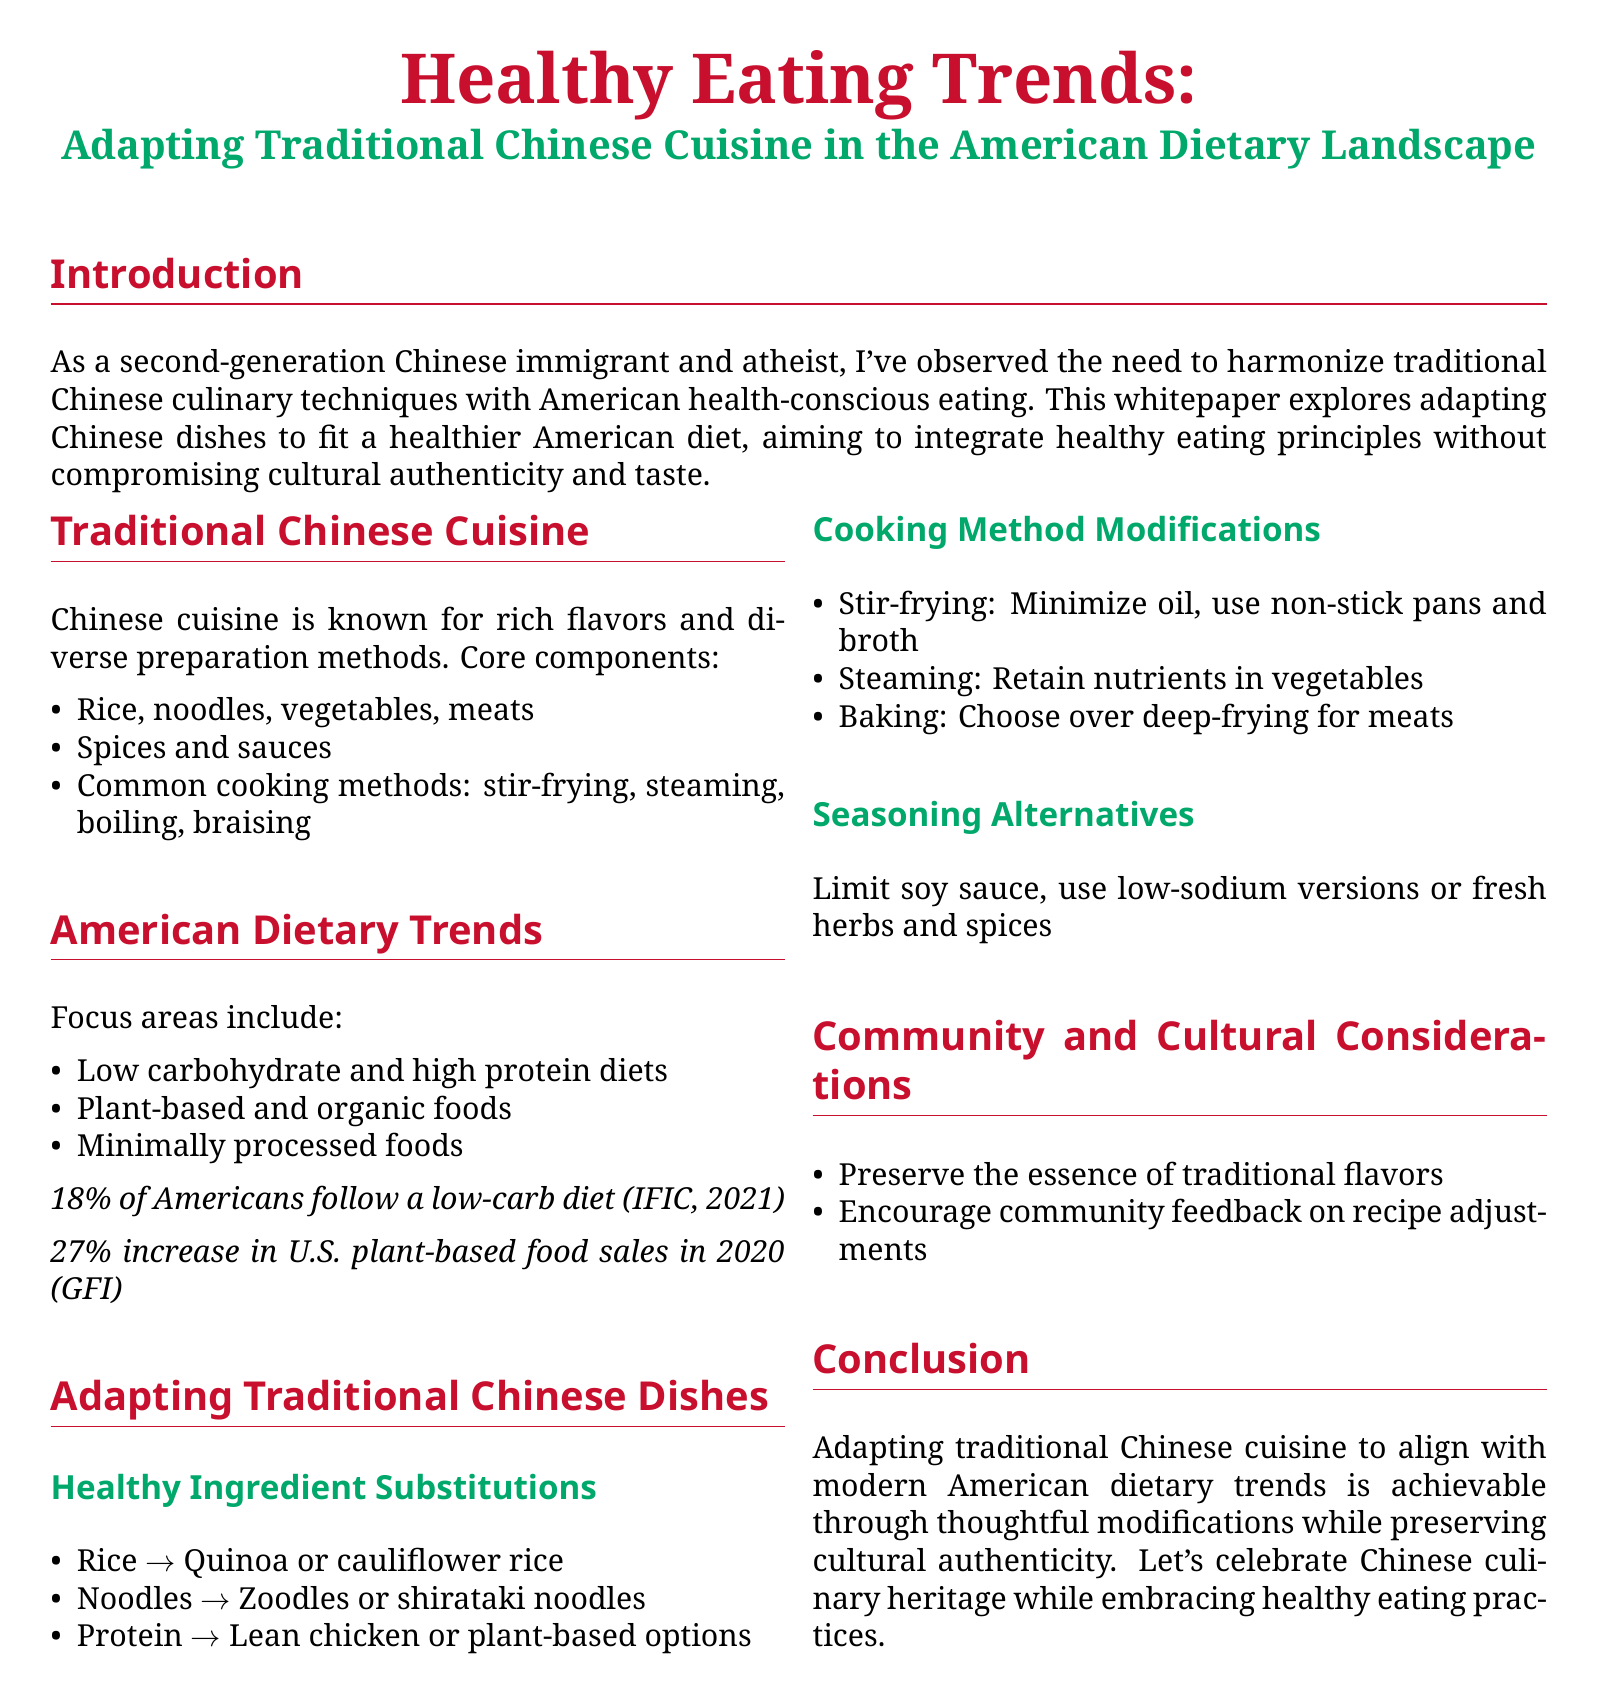What is the focus of American dietary trends? The focus areas include low carbohydrate and high protein diets, plant-based and organic foods, and minimally processed foods.
Answer: Low carbohydrate and high protein diets, plant-based and organic foods, minimally processed foods What percentage of Americans follow a low-carb diet? The document states that 18% of Americans follow a low-carb diet according to IFIC, 2021.
Answer: 18% What is a healthy substitution for rice mentioned in the document? The document suggests quinoa or cauliflower rice as substitutes for rice.
Answer: Quinoa or cauliflower rice What cooking method is recommended to retain nutrients in vegetables? The document advises steaming as a method to retain nutrients in vegetables.
Answer: Steaming What seasoning alternative is suggested to limit in traditional Chinese dishes? The document recommends limiting soy sauce.
Answer: Soy sauce How has U.S. plant-based food sales changed in 2020? The document mentions a 27% increase in U.S. plant-based food sales in 2020.
Answer: 27% What is the main goal of adapting traditional Chinese cuisine in the document? The document states the goal is to integrate healthy eating principles without compromising cultural authenticity and taste.
Answer: Integrate healthy eating principles without compromising cultural authenticity and taste What type of dish modification is suggested for protein? The document suggests using lean chicken or plant-based options as modifications for protein.
Answer: Lean chicken or plant-based options 